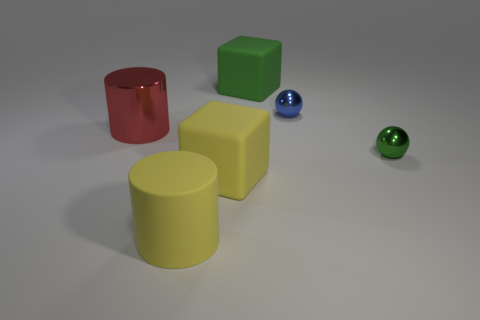Is the number of large red metal objects that are in front of the large yellow rubber block greater than the number of tiny blue metal things?
Your answer should be compact. No. Does the green thing that is on the right side of the blue shiny object have the same shape as the big red metal thing?
Make the answer very short. No. Are there any other things that are the same material as the tiny green thing?
Offer a very short reply. Yes. How many things are big brown rubber spheres or objects that are right of the green rubber object?
Offer a very short reply. 2. What is the size of the object that is both behind the big metallic thing and on the right side of the large green thing?
Your response must be concise. Small. Are there more green blocks that are in front of the tiny blue metallic sphere than tiny green shiny spheres in front of the green rubber block?
Keep it short and to the point. No. There is a blue metallic object; does it have the same shape as the green thing in front of the big red object?
Give a very brief answer. Yes. There is a big rubber object that is in front of the small blue ball and behind the big matte cylinder; what color is it?
Give a very brief answer. Yellow. What color is the matte cylinder?
Give a very brief answer. Yellow. Is the yellow cylinder made of the same material as the cylinder that is behind the small green metallic ball?
Keep it short and to the point. No. 